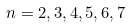<formula> <loc_0><loc_0><loc_500><loc_500>n = 2 , 3 , 4 , 5 , 6 , 7</formula> 